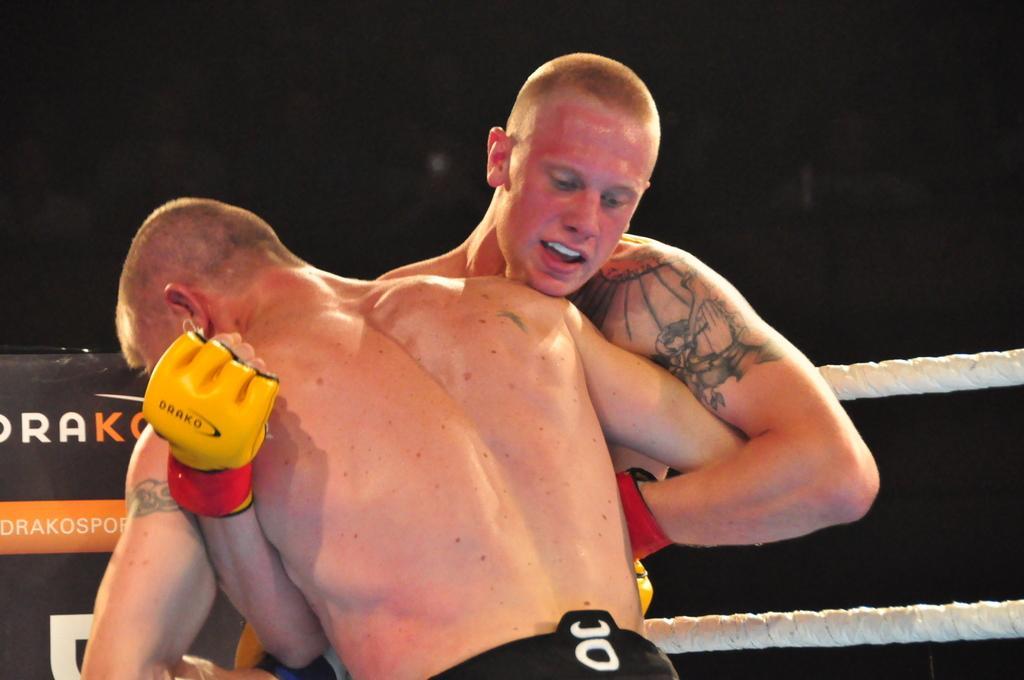Describe this image in one or two sentences. In this image we can see two men, ropes, and a banner. There is a dark background. 